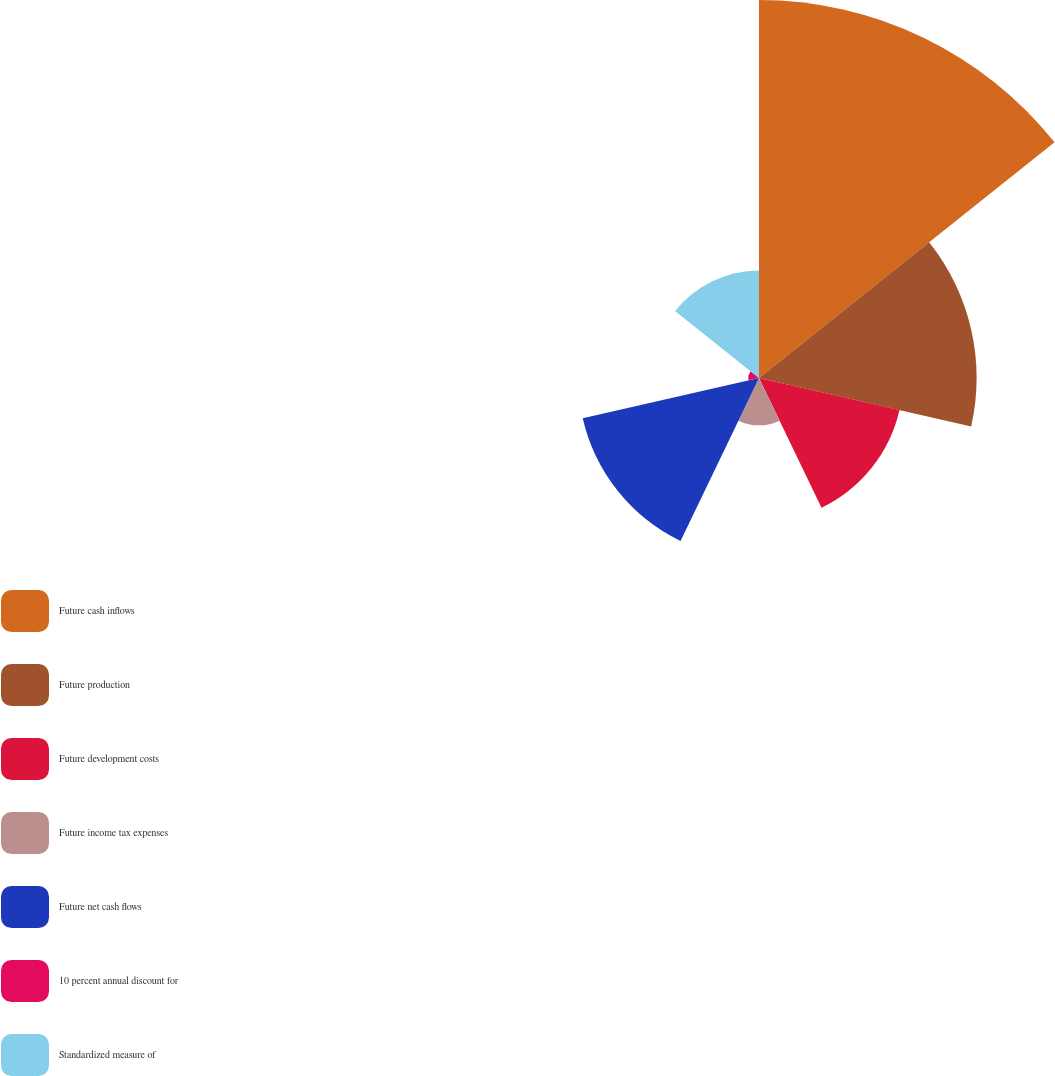<chart> <loc_0><loc_0><loc_500><loc_500><pie_chart><fcel>Future cash inflows<fcel>Future production<fcel>Future development costs<fcel>Future income tax expenses<fcel>Future net cash flows<fcel>10 percent annual discount for<fcel>Standardized measure of<nl><fcel>34.81%<fcel>20.04%<fcel>13.27%<fcel>4.36%<fcel>16.65%<fcel>0.98%<fcel>9.89%<nl></chart> 